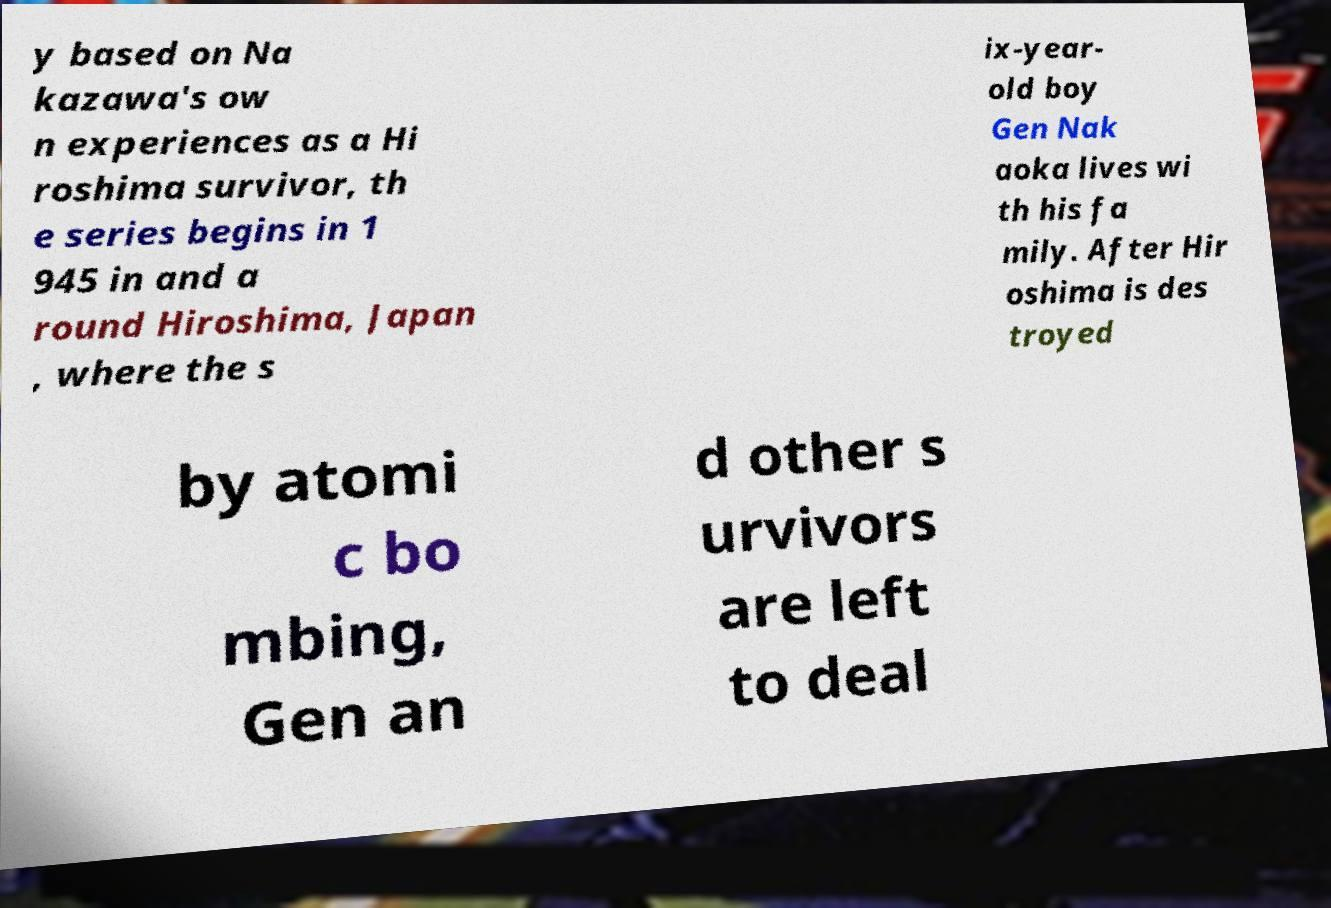Could you extract and type out the text from this image? y based on Na kazawa's ow n experiences as a Hi roshima survivor, th e series begins in 1 945 in and a round Hiroshima, Japan , where the s ix-year- old boy Gen Nak aoka lives wi th his fa mily. After Hir oshima is des troyed by atomi c bo mbing, Gen an d other s urvivors are left to deal 